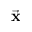<formula> <loc_0><loc_0><loc_500><loc_500>\vec { x }</formula> 